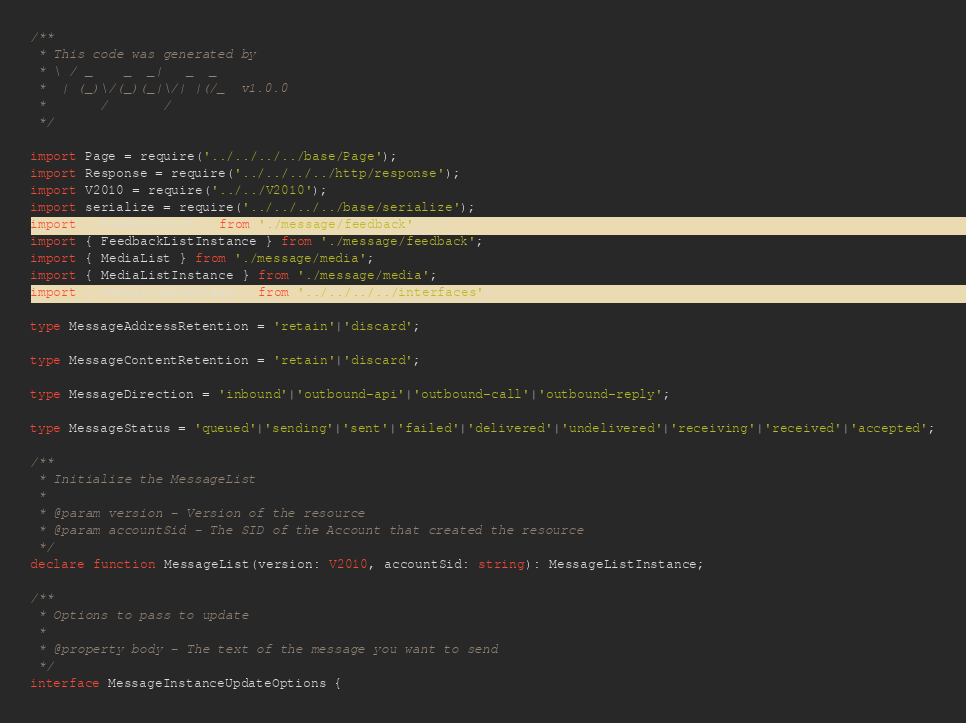<code> <loc_0><loc_0><loc_500><loc_500><_TypeScript_>/**
 * This code was generated by
 * \ / _    _  _|   _  _
 *  | (_)\/(_)(_|\/| |(/_  v1.0.0
 *       /       /
 */

import Page = require('../../../../base/Page');
import Response = require('../../../../http/response');
import V2010 = require('../../V2010');
import serialize = require('../../../../base/serialize');
import { FeedbackList } from './message/feedback';
import { FeedbackListInstance } from './message/feedback';
import { MediaList } from './message/media';
import { MediaListInstance } from './message/media';
import { SerializableClass } from '../../../../interfaces';

type MessageAddressRetention = 'retain'|'discard';

type MessageContentRetention = 'retain'|'discard';

type MessageDirection = 'inbound'|'outbound-api'|'outbound-call'|'outbound-reply';

type MessageStatus = 'queued'|'sending'|'sent'|'failed'|'delivered'|'undelivered'|'receiving'|'received'|'accepted';

/**
 * Initialize the MessageList
 *
 * @param version - Version of the resource
 * @param accountSid - The SID of the Account that created the resource
 */
declare function MessageList(version: V2010, accountSid: string): MessageListInstance;

/**
 * Options to pass to update
 *
 * @property body - The text of the message you want to send
 */
interface MessageInstanceUpdateOptions {</code> 